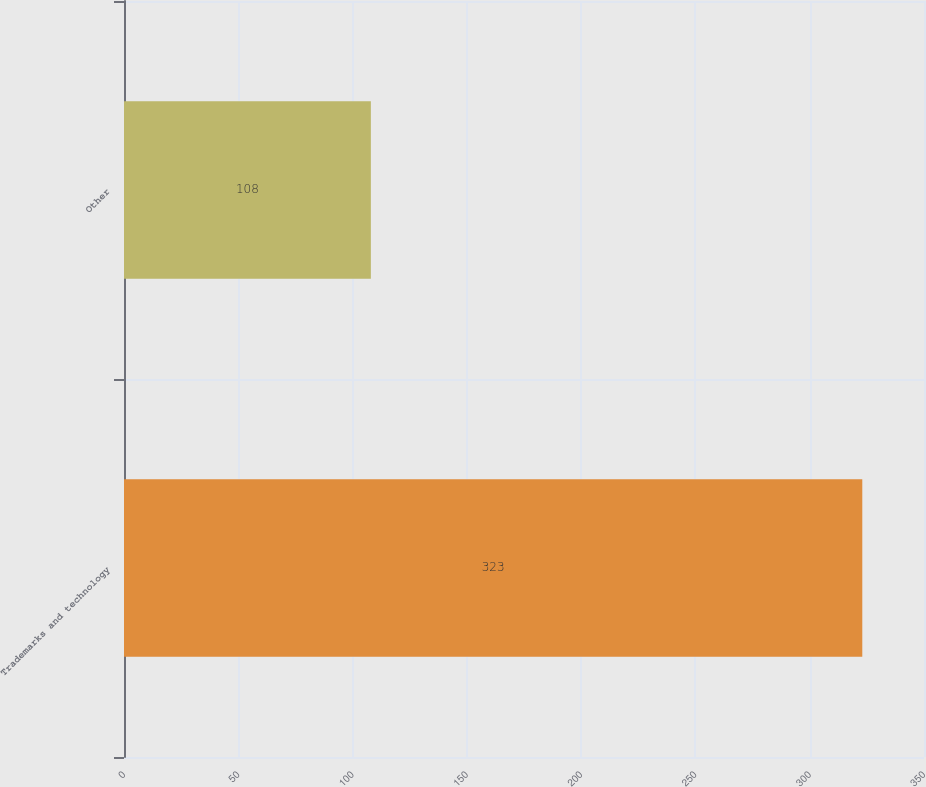Convert chart. <chart><loc_0><loc_0><loc_500><loc_500><bar_chart><fcel>Trademarks and technology<fcel>Other<nl><fcel>323<fcel>108<nl></chart> 